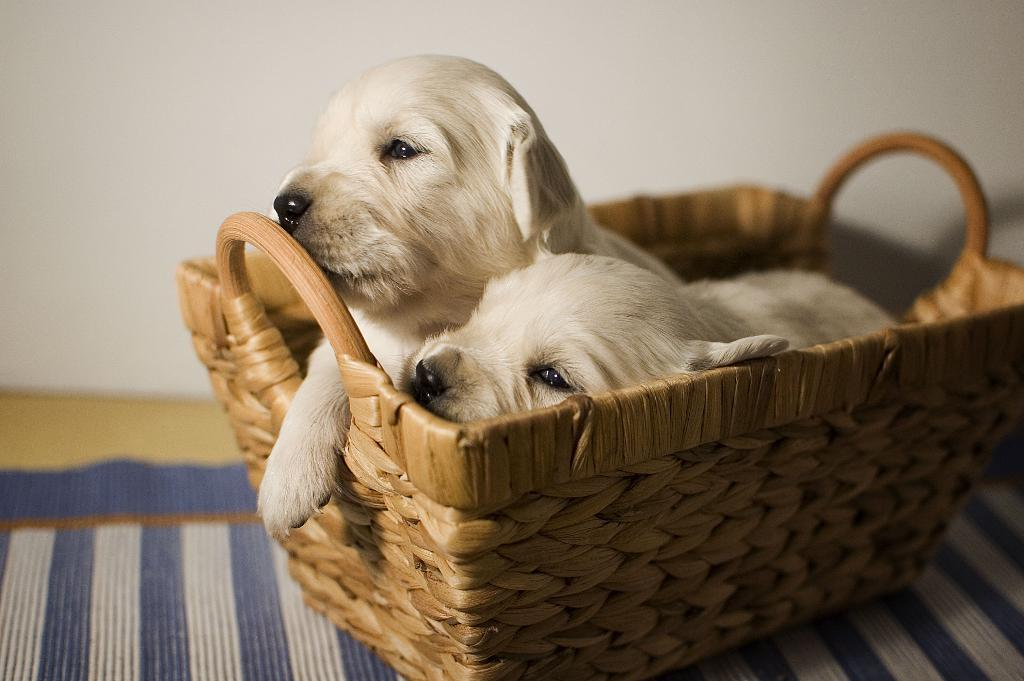How many puppies are in the basket in the image? There are two puppies in the basket in the image. Where is the basket located? The basket is on the ground. What is on the ground beneath the basket? There is a cloth on the ground. What can be seen in the background of the image? The wall is visible in the image. How is the basket placed on the ground? The basket is kept on the cloth. What type of pen is used to draw on the wall in the image? There is no pen or drawing on the wall in the image; it only shows two puppies in a basket on a cloth. 